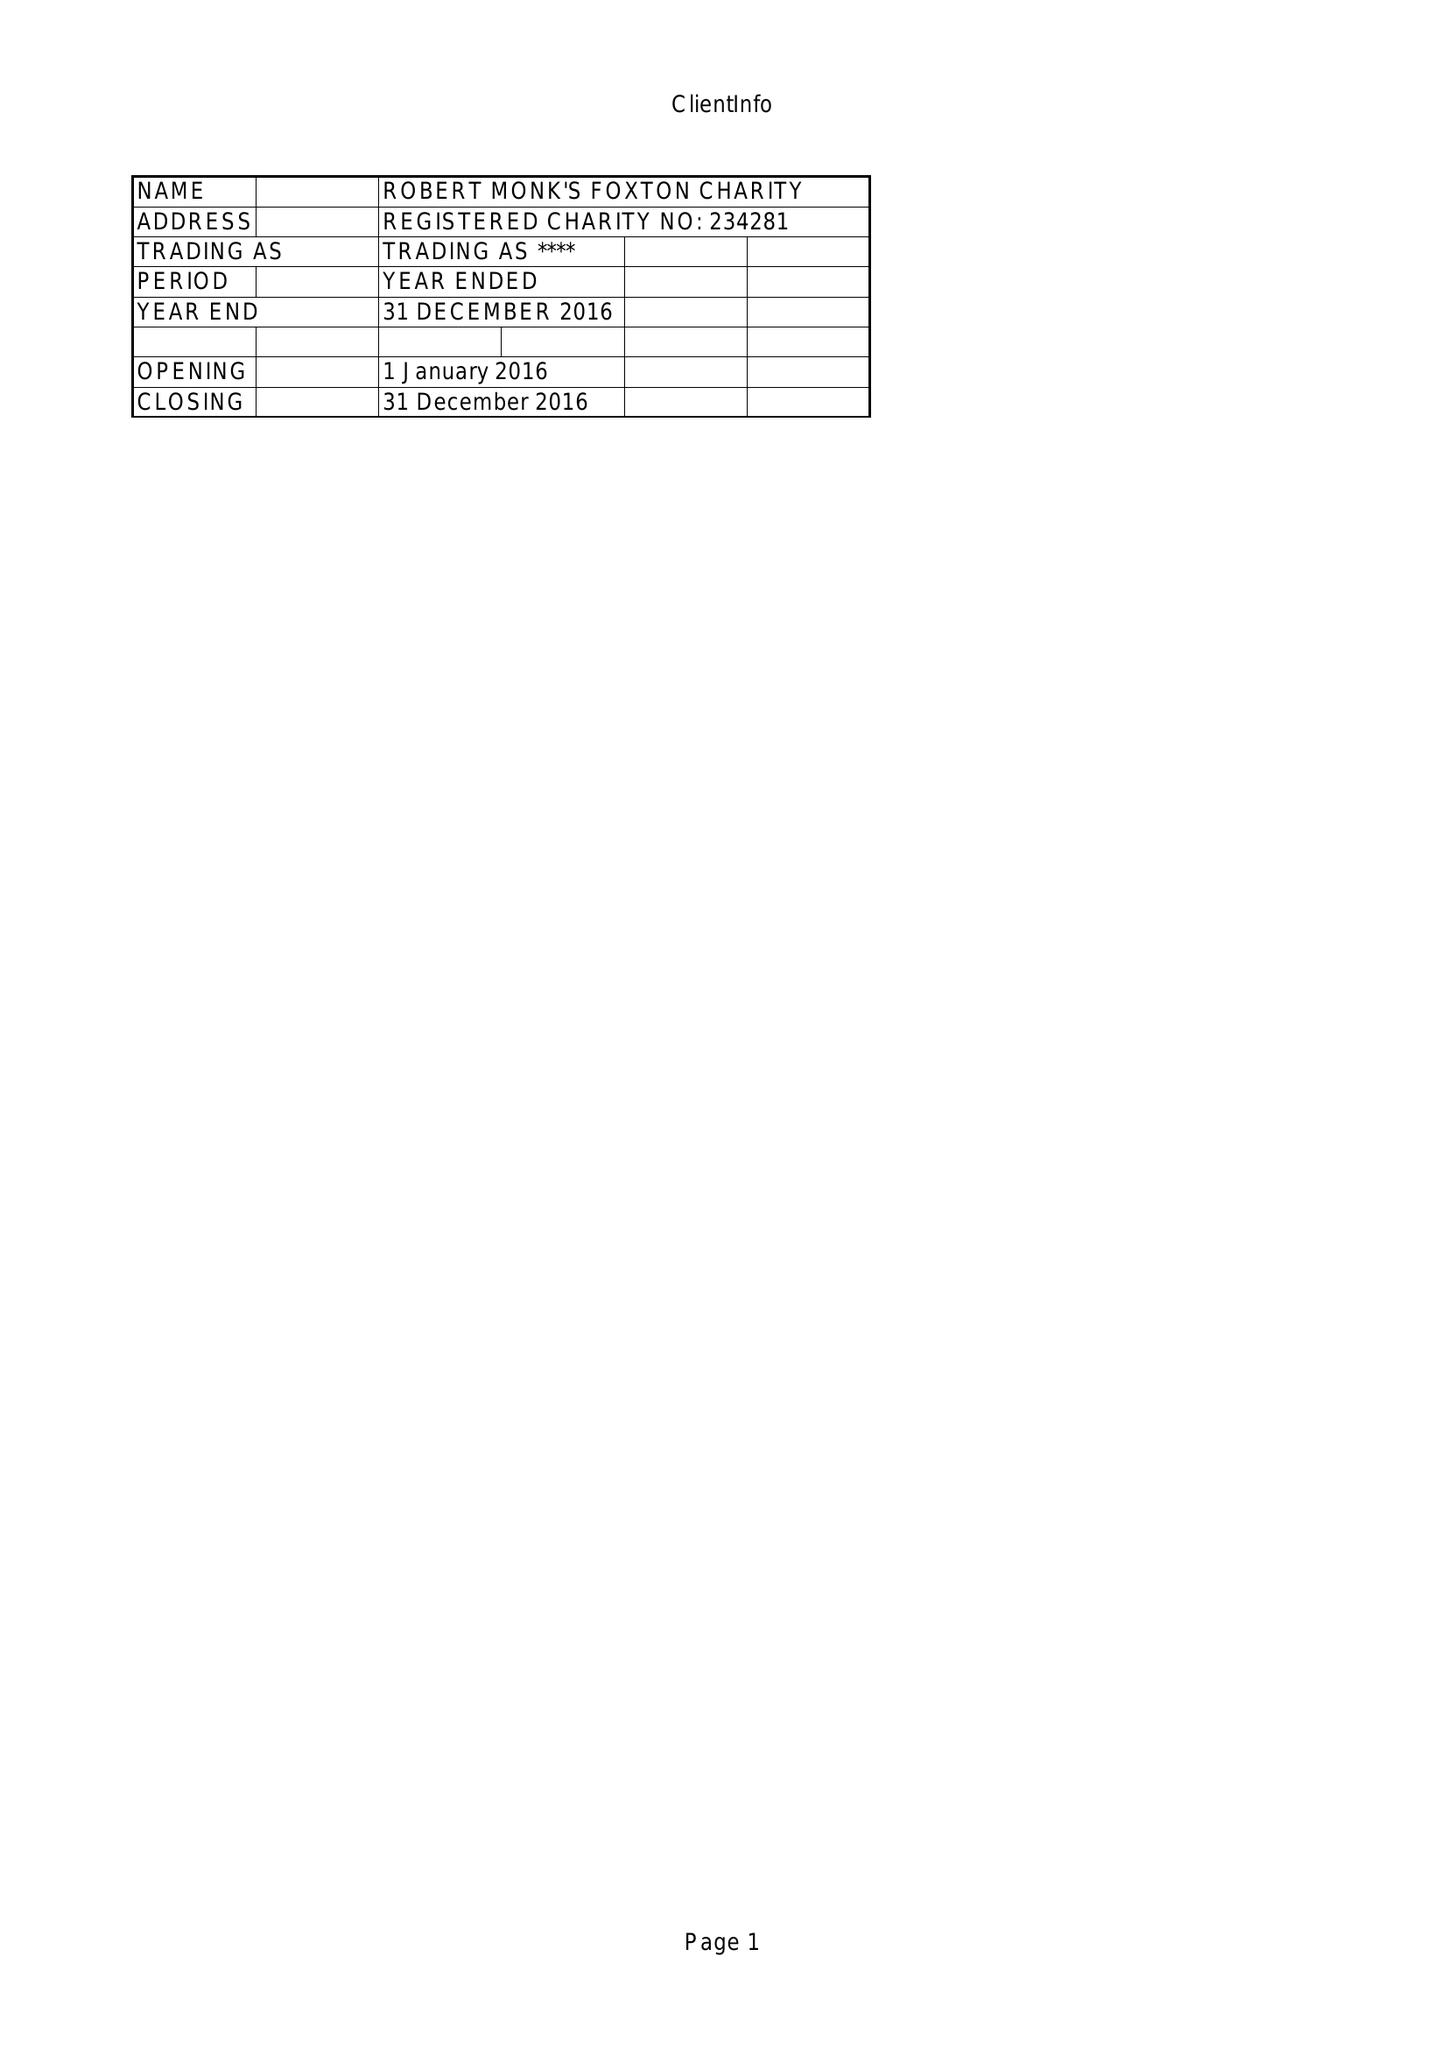What is the value for the spending_annually_in_british_pounds?
Answer the question using a single word or phrase. 30839.00 